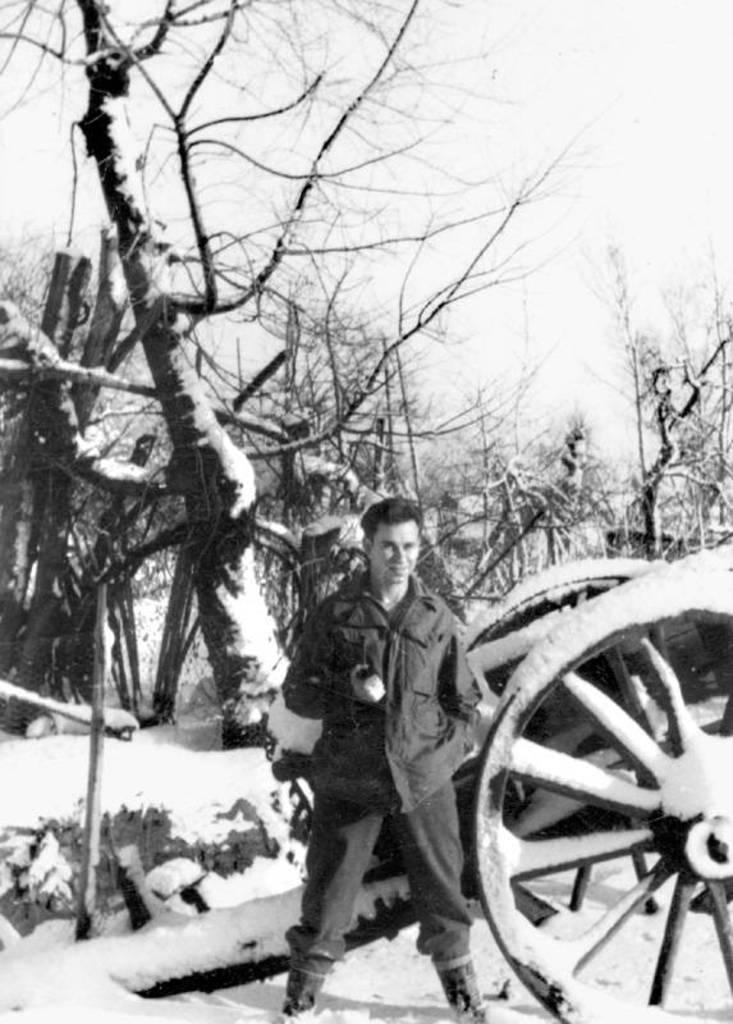What is the color scheme of the image? The image is black and white. Who or what can be seen in the image? There is a man standing in the image. What type of natural environment is visible in the image? There are trees visible in the image. What type of vehicle is present in the image? There is a cart vehicle in the image. What is visible in the background of the image? The sky is visible in the image. What weather condition is depicted in the image? There is snow in the image. How does the man maintain a connection with the sea in the image? There is no sea present in the image, so it is not possible to determine how the man might maintain a connection with it. 